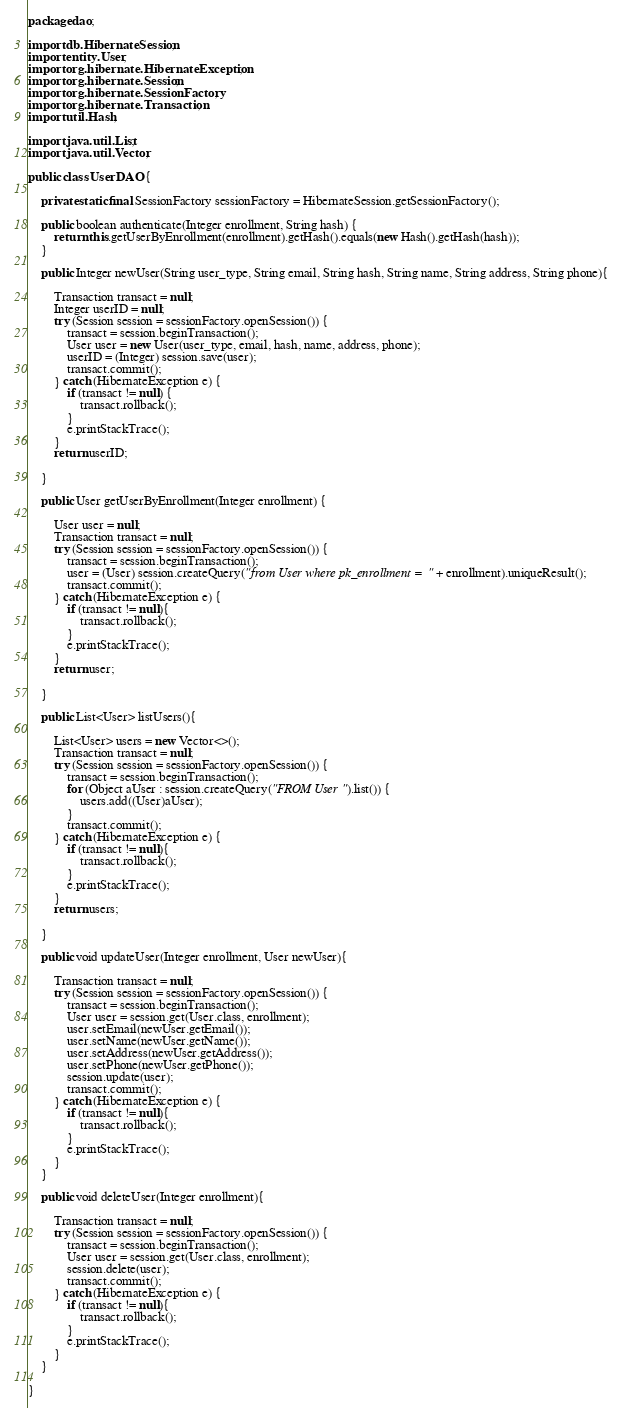<code> <loc_0><loc_0><loc_500><loc_500><_Java_>package dao;

import db.HibernateSession;
import entity.User;
import org.hibernate.HibernateException;
import org.hibernate.Session;
import org.hibernate.SessionFactory;
import org.hibernate.Transaction;
import util.Hash;

import java.util.List;
import java.util.Vector;

public class UserDAO {

    private static final SessionFactory sessionFactory = HibernateSession.getSessionFactory();

    public boolean authenticate(Integer enrollment, String hash) {
        return this.getUserByEnrollment(enrollment).getHash().equals(new Hash().getHash(hash));
    }

    public Integer newUser(String user_type, String email, String hash, String name, String address, String phone){

        Transaction transact = null;
        Integer userID = null;
        try (Session session = sessionFactory.openSession()) {
            transact = session.beginTransaction();
            User user = new User(user_type, email, hash, name, address, phone);
            userID = (Integer) session.save(user);
            transact.commit();
        } catch (HibernateException e) {
            if (transact != null) {
                transact.rollback();
            }
            e.printStackTrace();
        }
        return userID;

    }

    public User getUserByEnrollment(Integer enrollment) {

        User user = null;
        Transaction transact = null;
        try (Session session = sessionFactory.openSession()) {
            transact = session.beginTransaction();
            user = (User) session.createQuery("from User where pk_enrollment = " + enrollment).uniqueResult();
            transact.commit();
        } catch (HibernateException e) {
            if (transact != null){
                transact.rollback();
            }
            e.printStackTrace();
        }
        return user;

    }

    public List<User> listUsers(){

        List<User> users = new Vector<>();
        Transaction transact = null;
        try (Session session = sessionFactory.openSession()) {
            transact = session.beginTransaction();
            for (Object aUser : session.createQuery("FROM User").list()) {
                users.add((User)aUser);
            }
            transact.commit();
        } catch (HibernateException e) {
            if (transact != null){
                transact.rollback();
            }
            e.printStackTrace();
        }
        return users;

    }

    public void updateUser(Integer enrollment, User newUser){

        Transaction transact = null;
        try (Session session = sessionFactory.openSession()) {
            transact = session.beginTransaction();
            User user = session.get(User.class, enrollment);
            user.setEmail(newUser.getEmail());
            user.setName(newUser.getName());
            user.setAddress(newUser.getAddress());
            user.setPhone(newUser.getPhone());
            session.update(user);
            transact.commit();
        } catch (HibernateException e) {
            if (transact != null){
                transact.rollback();
            }
            e.printStackTrace();
        }
    }

    public void deleteUser(Integer enrollment){

        Transaction transact = null;
        try (Session session = sessionFactory.openSession()) {
            transact = session.beginTransaction();
            User user = session.get(User.class, enrollment);
            session.delete(user);
            transact.commit();
        } catch (HibernateException e) {
            if (transact != null){
                transact.rollback();
            }
            e.printStackTrace();
        }
    }

}
</code> 